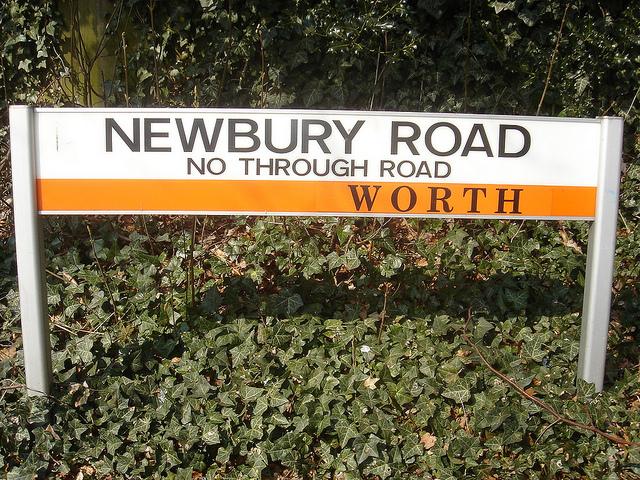What are the words on the sign?
Concise answer only. Newbury road no through road worth. Is there snow on the ground?
Give a very brief answer. No. What three colors are on the sign?
Answer briefly. White, black and orange. What is on the sign?
Quick response, please. Newbury road. What color is the sign?
Quick response, please. White and orange. 